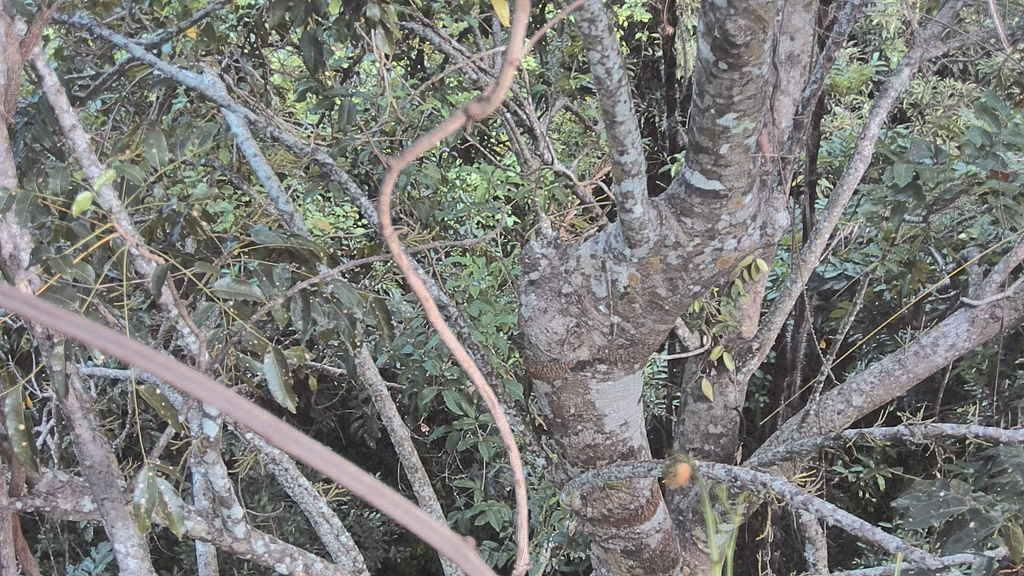What type of vegetation can be seen in the image? There are trees in the image. What time of day is depicted in the image? The provided facts do not mention the time of day, so it cannot be determined from the image. 